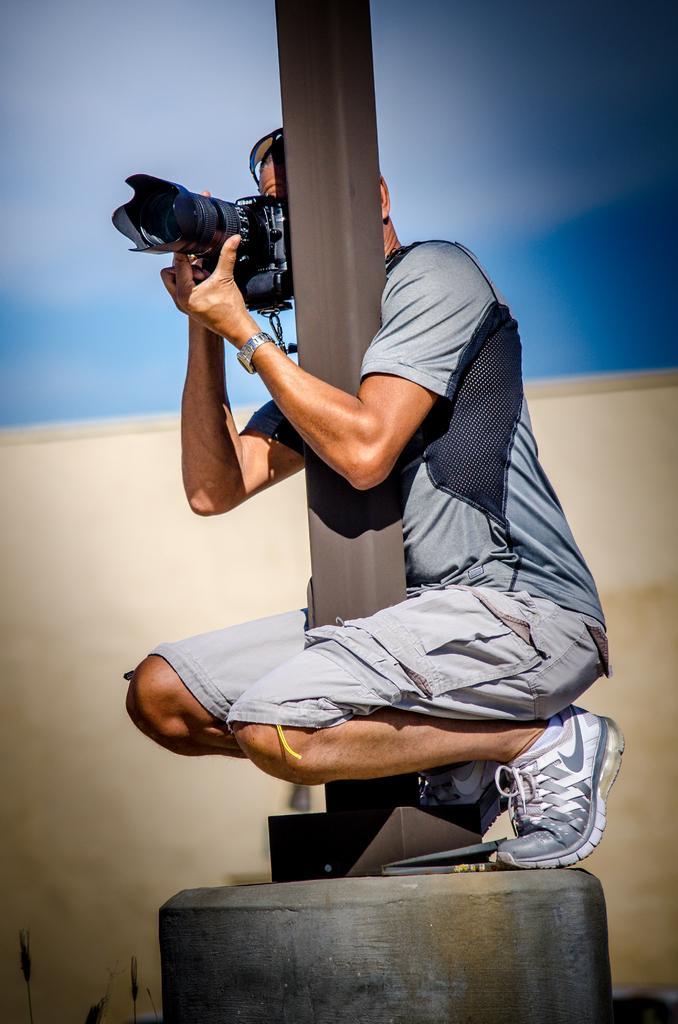Could you give a brief overview of what you see in this image? In this image a person wearing short and T-shirt holding a camera in his hands crouching down on pole. 